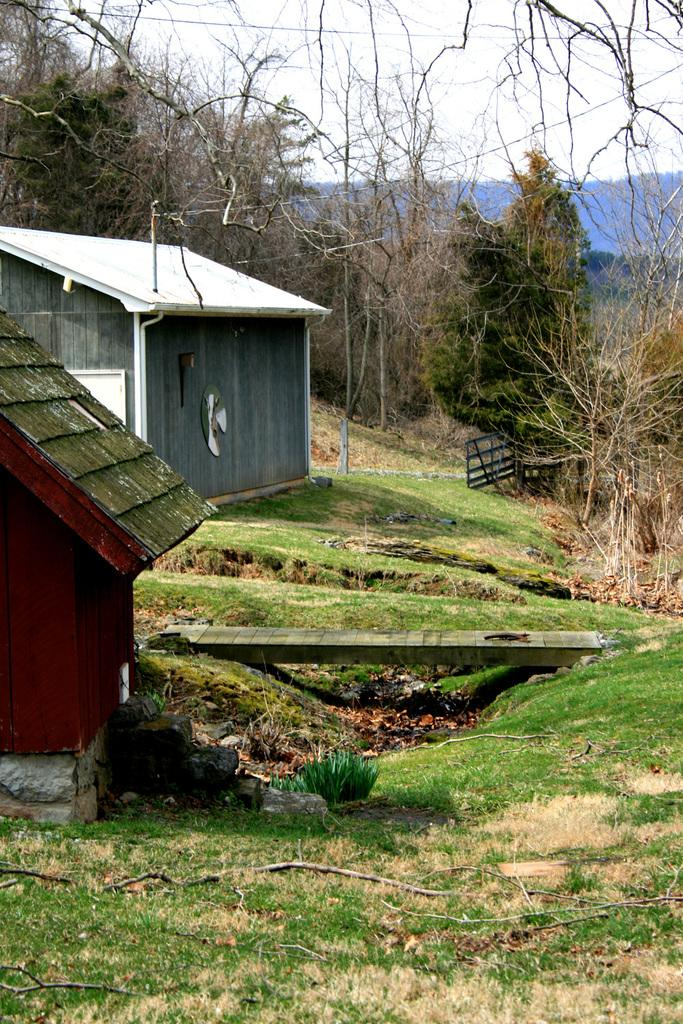What type of vegetation is at the bottom of the image? There is grass at the bottom of the image. What structures are located on the left side of the image? There are two sheds on the left side of the image. What can be seen behind the sheds? There are trees behind the sheds. What objects are visible in the image that are not sheds or trees? There are poles visible in the image. What is visible at the top of the image? The sky is visible at the top of the image. How many apples are hanging from the poles in the image? There are no apples present in the image; only grass, sheds, trees, and poles are visible. What type of gold is present in the image? There is no gold present in the image. Is there a scale visible in the image? There is no scale present in the image. 